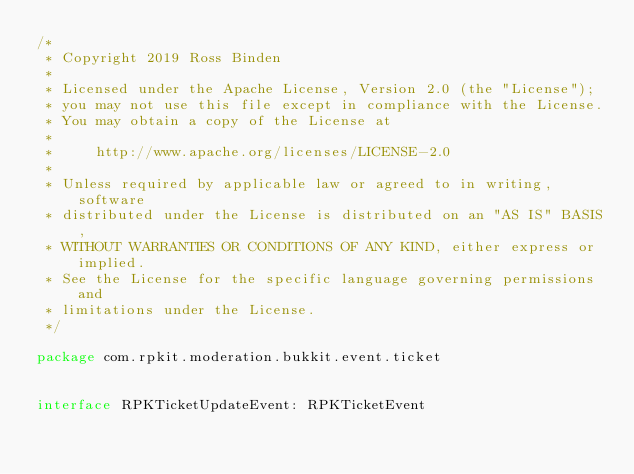<code> <loc_0><loc_0><loc_500><loc_500><_Kotlin_>/*
 * Copyright 2019 Ross Binden
 *
 * Licensed under the Apache License, Version 2.0 (the "License");
 * you may not use this file except in compliance with the License.
 * You may obtain a copy of the License at
 *
 *     http://www.apache.org/licenses/LICENSE-2.0
 *
 * Unless required by applicable law or agreed to in writing, software
 * distributed under the License is distributed on an "AS IS" BASIS,
 * WITHOUT WARRANTIES OR CONDITIONS OF ANY KIND, either express or implied.
 * See the License for the specific language governing permissions and
 * limitations under the License.
 */

package com.rpkit.moderation.bukkit.event.ticket


interface RPKTicketUpdateEvent: RPKTicketEvent</code> 